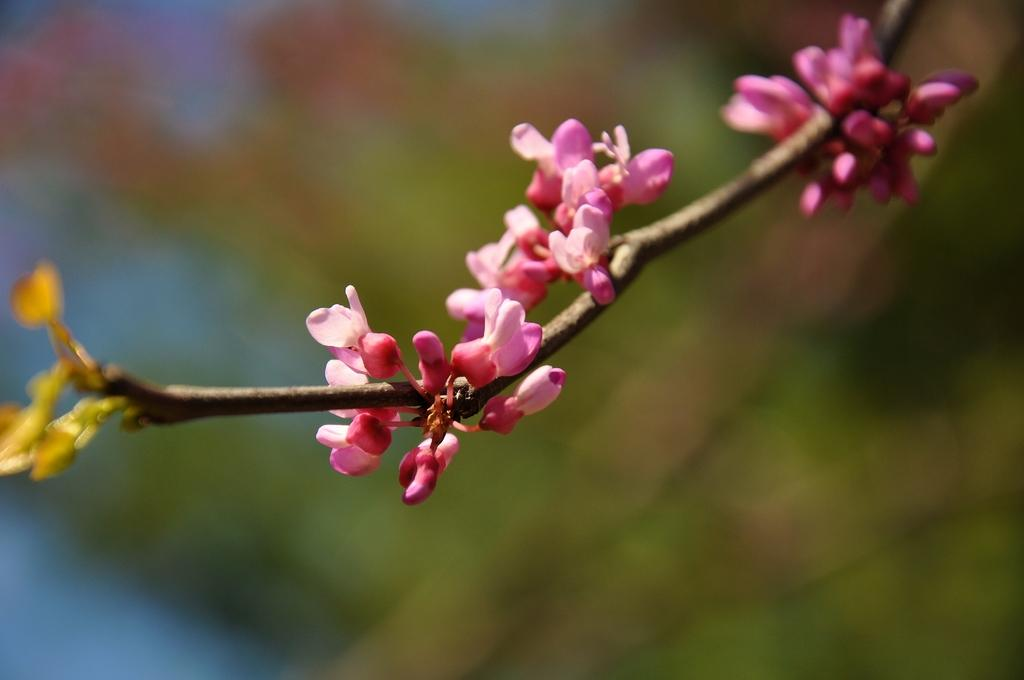What type of plant is visible in the image? There are flowers on the stem of a plant in the image. Can you describe the flowers on the plant? Unfortunately, the facts provided do not give any details about the flowers, so we cannot describe them. How does the plant compare to a popcorn machine in the image? There is no popcorn machine present in the image, so it is not possible to make a comparison. 